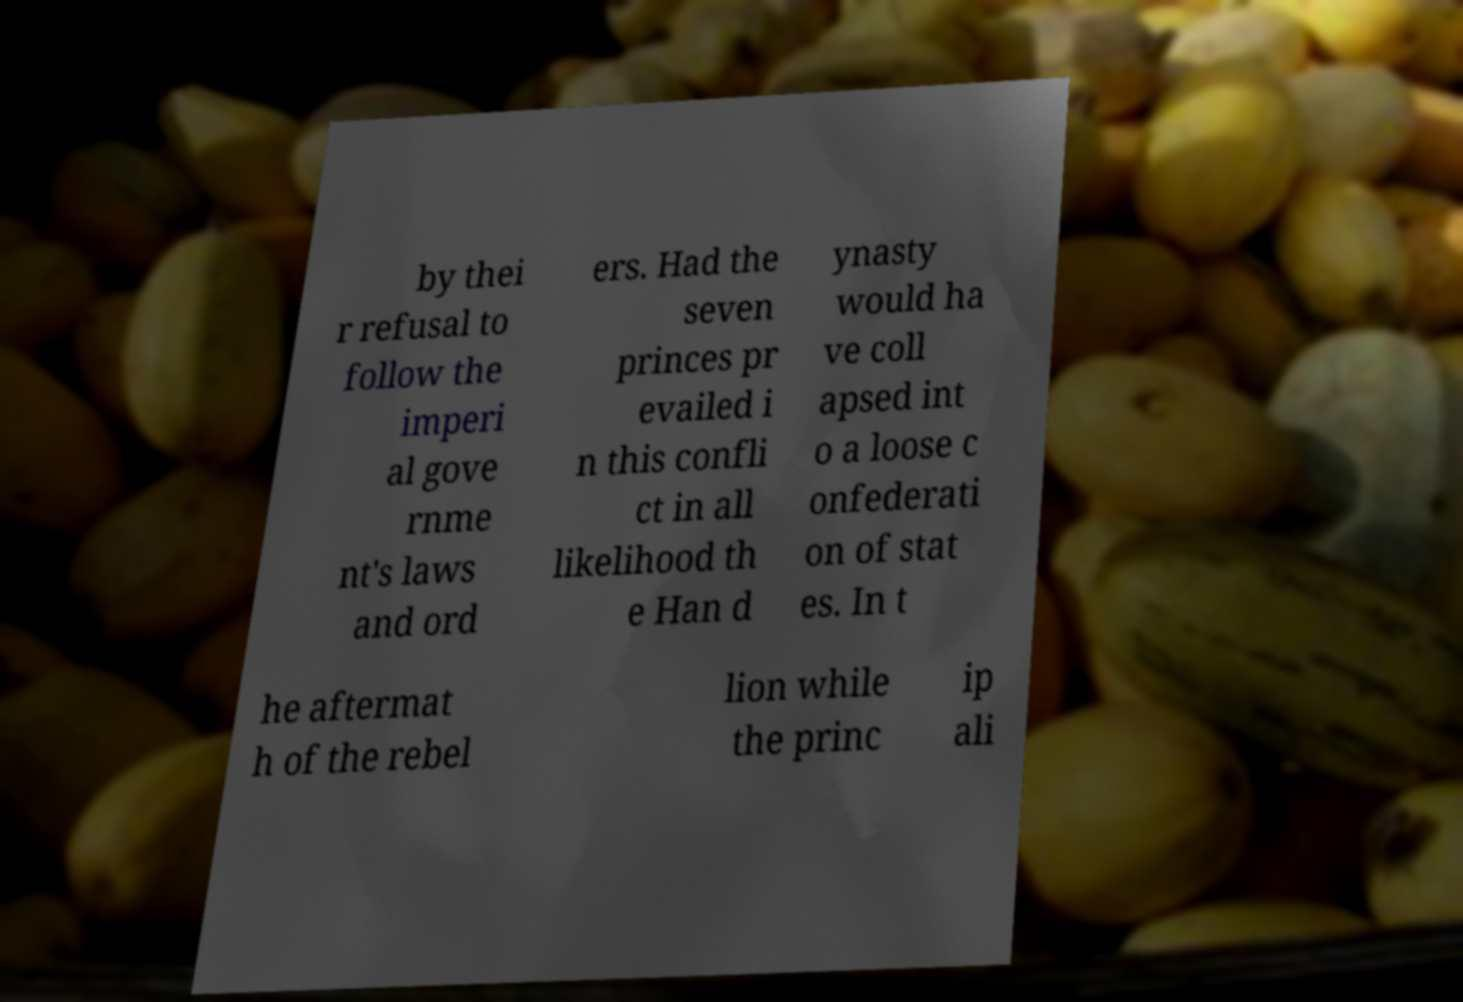Can you accurately transcribe the text from the provided image for me? by thei r refusal to follow the imperi al gove rnme nt's laws and ord ers. Had the seven princes pr evailed i n this confli ct in all likelihood th e Han d ynasty would ha ve coll apsed int o a loose c onfederati on of stat es. In t he aftermat h of the rebel lion while the princ ip ali 